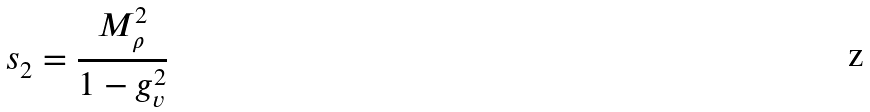Convert formula to latex. <formula><loc_0><loc_0><loc_500><loc_500>s _ { 2 } = \frac { M _ { \rho } ^ { 2 } } { 1 - g _ { v } ^ { 2 } }</formula> 